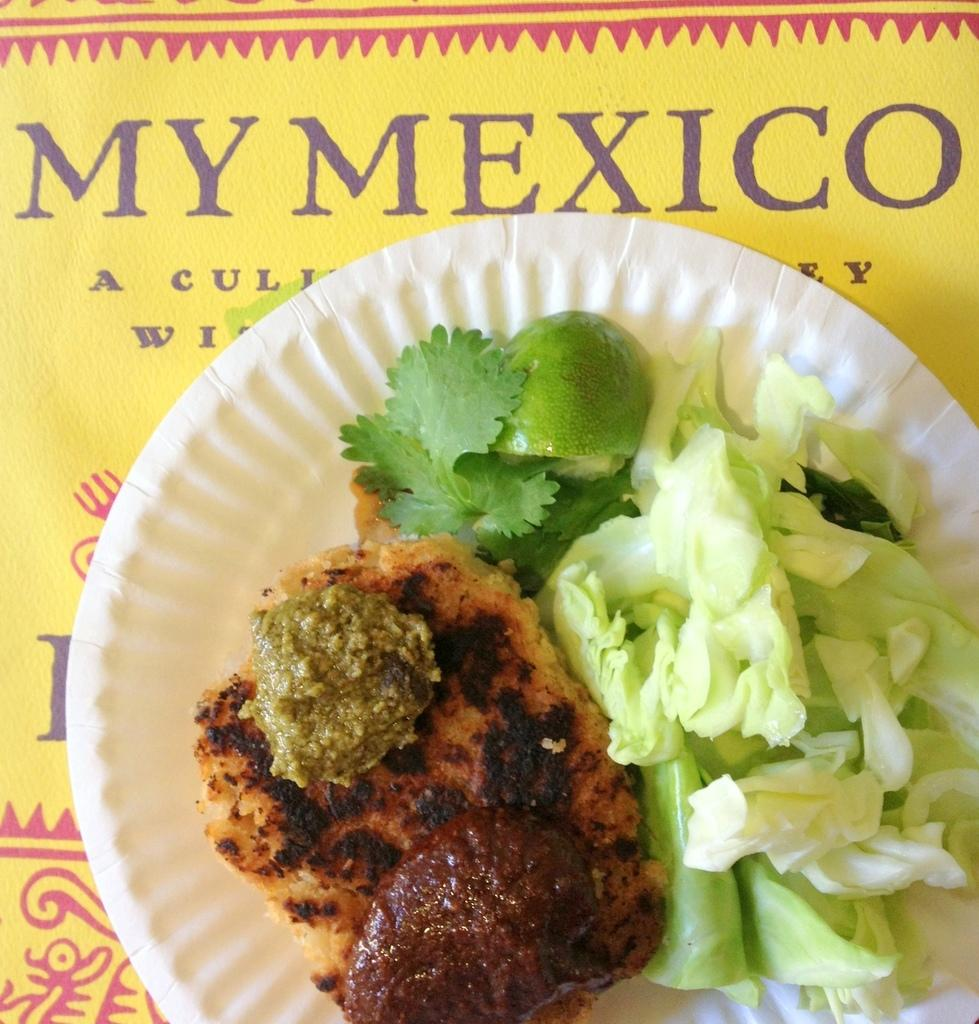What is on the paper plate in the image? There is food on a paper plate in the image. What is the paper plate placed on? The paper plate is on a yellow color platform. Is there any text visible on the platform? Yes, there is text written on the platform. What type of pain can be seen on the faces of the people in the image? There are no people present in the image, so it is not possible to determine if they are experiencing any pain. 